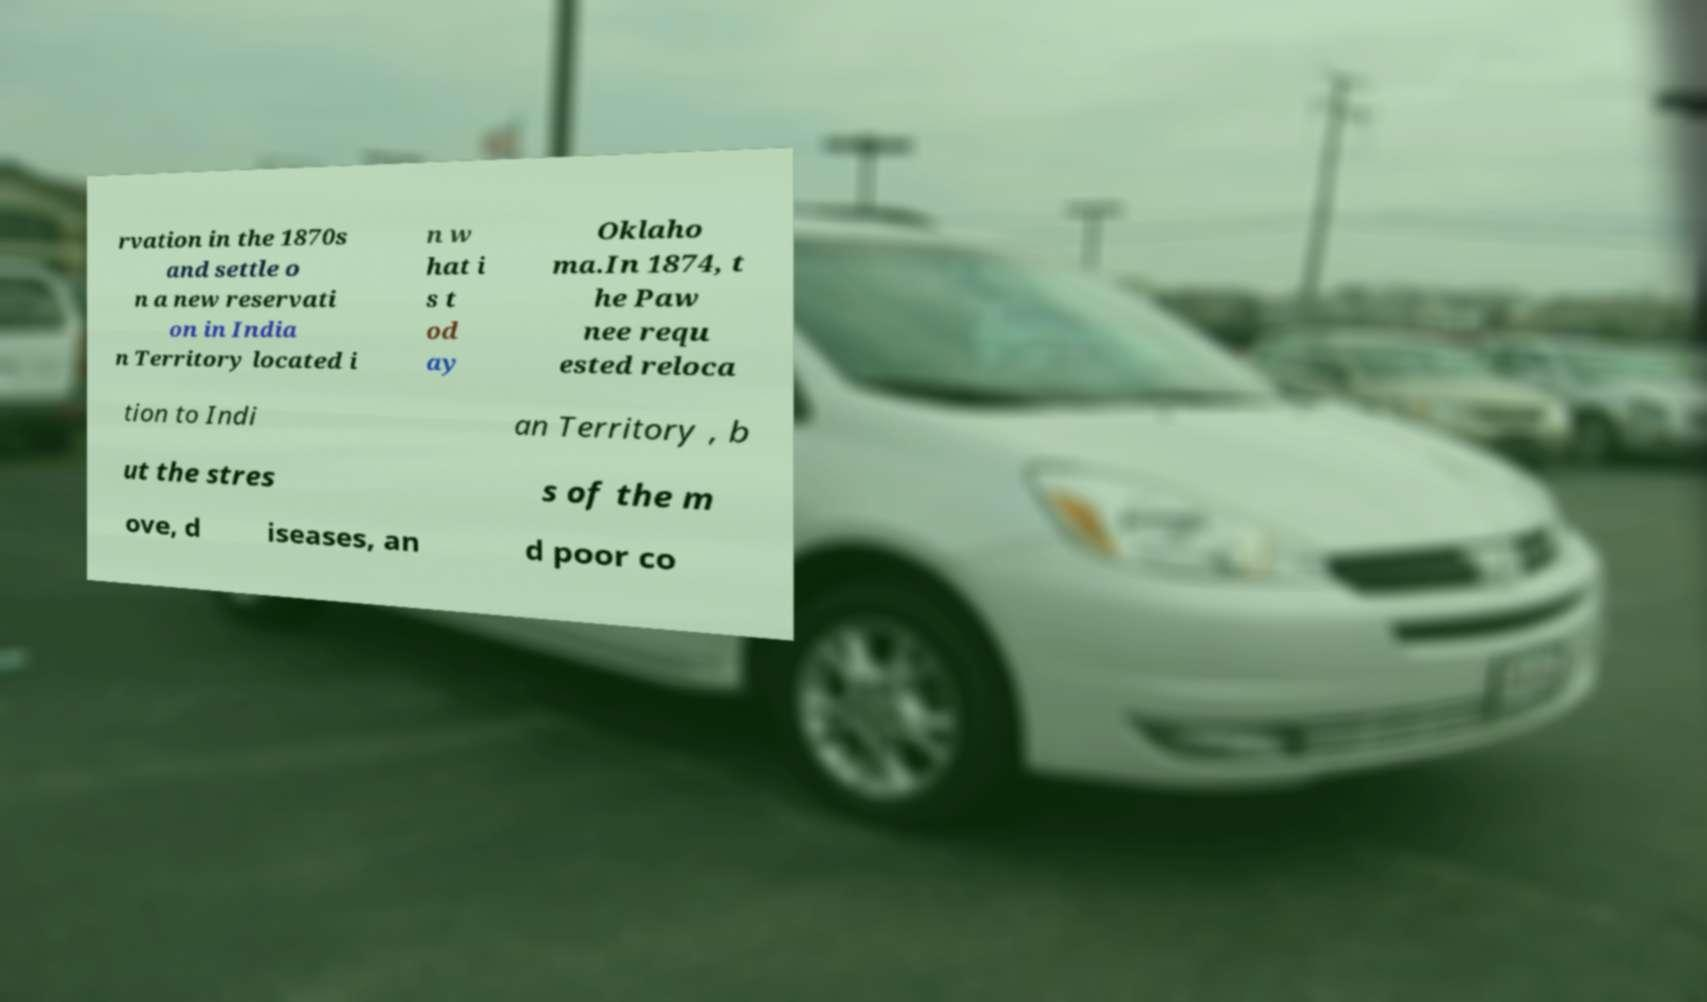Please identify and transcribe the text found in this image. rvation in the 1870s and settle o n a new reservati on in India n Territory located i n w hat i s t od ay Oklaho ma.In 1874, t he Paw nee requ ested reloca tion to Indi an Territory , b ut the stres s of the m ove, d iseases, an d poor co 